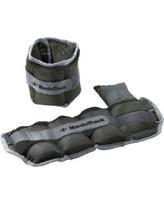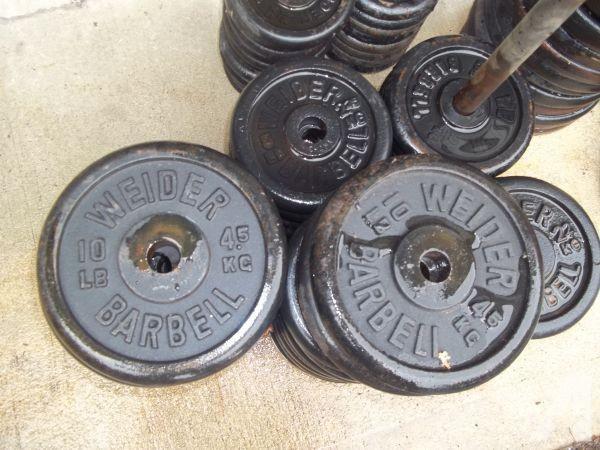The first image is the image on the left, the second image is the image on the right. Evaluate the accuracy of this statement regarding the images: "The left and right image contains the same number of dumbells.". Is it true? Answer yes or no. No. The first image is the image on the left, the second image is the image on the right. Analyze the images presented: Is the assertion "Each image shows one overlapping pair of dumbbells, but the left image shows the overlapping dumbbell almost vertical, and the right image shows the overlapping dumbbell more diagonal." valid? Answer yes or no. No. 